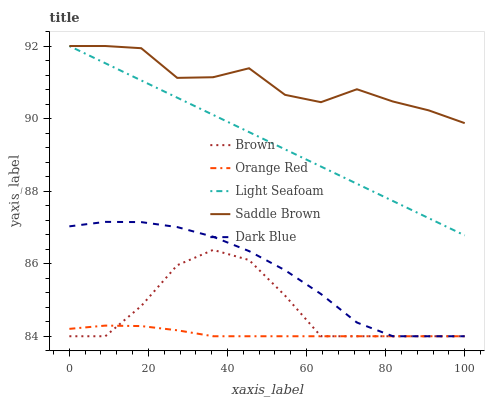Does Orange Red have the minimum area under the curve?
Answer yes or no. Yes. Does Saddle Brown have the maximum area under the curve?
Answer yes or no. Yes. Does Dark Blue have the minimum area under the curve?
Answer yes or no. No. Does Dark Blue have the maximum area under the curve?
Answer yes or no. No. Is Light Seafoam the smoothest?
Answer yes or no. Yes. Is Saddle Brown the roughest?
Answer yes or no. Yes. Is Dark Blue the smoothest?
Answer yes or no. No. Is Dark Blue the roughest?
Answer yes or no. No. Does Brown have the lowest value?
Answer yes or no. Yes. Does Light Seafoam have the lowest value?
Answer yes or no. No. Does Saddle Brown have the highest value?
Answer yes or no. Yes. Does Dark Blue have the highest value?
Answer yes or no. No. Is Orange Red less than Saddle Brown?
Answer yes or no. Yes. Is Light Seafoam greater than Brown?
Answer yes or no. Yes. Does Light Seafoam intersect Saddle Brown?
Answer yes or no. Yes. Is Light Seafoam less than Saddle Brown?
Answer yes or no. No. Is Light Seafoam greater than Saddle Brown?
Answer yes or no. No. Does Orange Red intersect Saddle Brown?
Answer yes or no. No. 